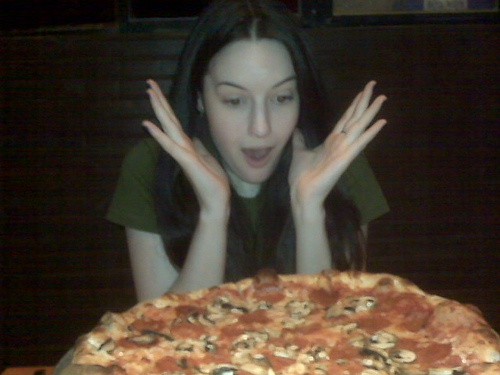Describe the objects in this image and their specific colors. I can see people in black, darkgray, and gray tones, pizza in black, gray, tan, and brown tones, and dining table in maroon and black tones in this image. 